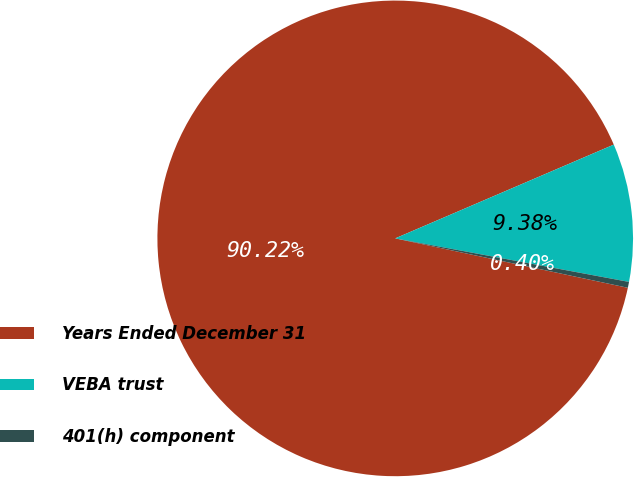Convert chart. <chart><loc_0><loc_0><loc_500><loc_500><pie_chart><fcel>Years Ended December 31<fcel>VEBA trust<fcel>401(h) component<nl><fcel>90.21%<fcel>9.38%<fcel>0.4%<nl></chart> 